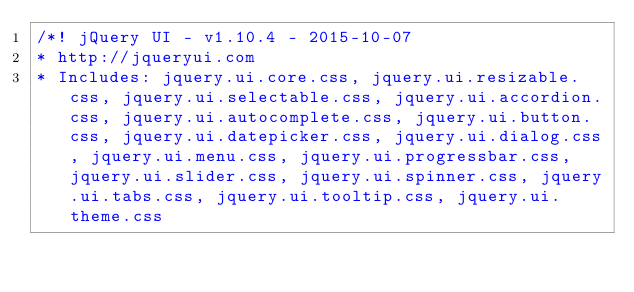Convert code to text. <code><loc_0><loc_0><loc_500><loc_500><_CSS_>/*! jQuery UI - v1.10.4 - 2015-10-07
* http://jqueryui.com
* Includes: jquery.ui.core.css, jquery.ui.resizable.css, jquery.ui.selectable.css, jquery.ui.accordion.css, jquery.ui.autocomplete.css, jquery.ui.button.css, jquery.ui.datepicker.css, jquery.ui.dialog.css, jquery.ui.menu.css, jquery.ui.progressbar.css, jquery.ui.slider.css, jquery.ui.spinner.css, jquery.ui.tabs.css, jquery.ui.tooltip.css, jquery.ui.theme.css</code> 